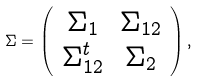Convert formula to latex. <formula><loc_0><loc_0><loc_500><loc_500>\Sigma = \left ( \begin{array} { c c } \Sigma _ { 1 } & \Sigma _ { 1 2 } \\ \Sigma _ { 1 2 } ^ { t } & \Sigma _ { 2 } \\ \end{array} \right ) ,</formula> 